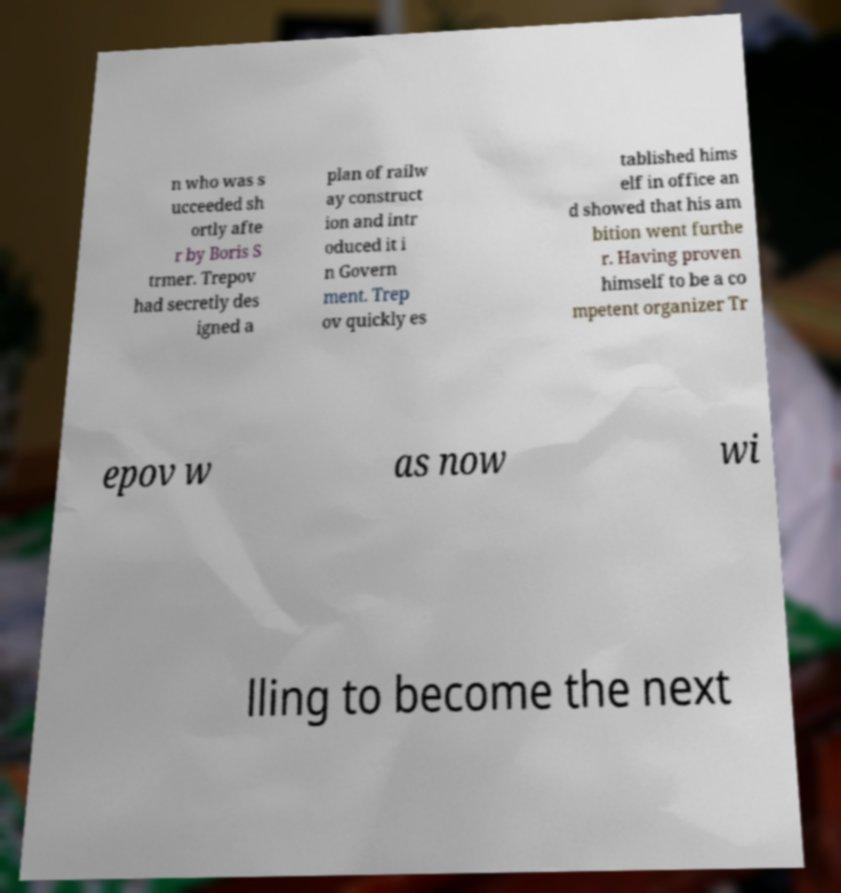Could you assist in decoding the text presented in this image and type it out clearly? n who was s ucceeded sh ortly afte r by Boris S trmer. Trepov had secretly des igned a plan of railw ay construct ion and intr oduced it i n Govern ment. Trep ov quickly es tablished hims elf in office an d showed that his am bition went furthe r. Having proven himself to be a co mpetent organizer Tr epov w as now wi lling to become the next 